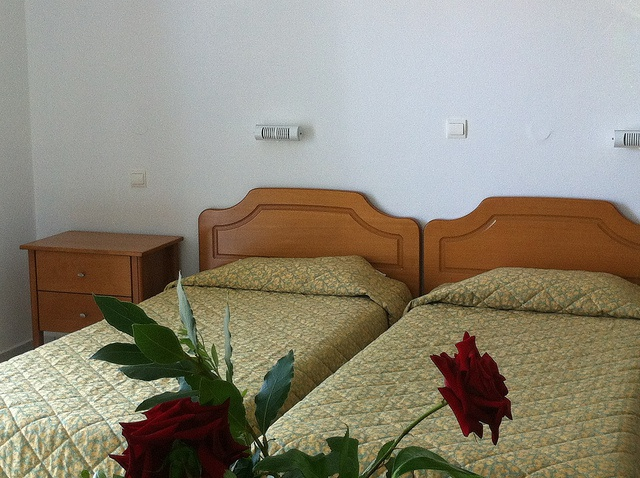Describe the objects in this image and their specific colors. I can see bed in darkgray and olive tones, bed in darkgray, tan, olive, and beige tones, and potted plant in darkgray, black, maroon, olive, and gray tones in this image. 